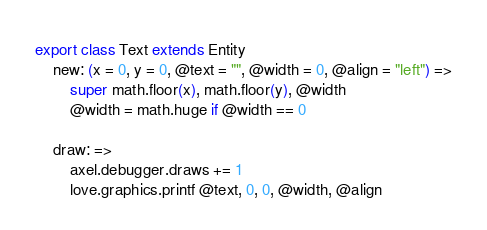<code> <loc_0><loc_0><loc_500><loc_500><_MoonScript_>export class Text extends Entity
	new: (x = 0, y = 0, @text = "", @width = 0, @align = "left") =>
		super math.floor(x), math.floor(y), @width
		@width = math.huge if @width == 0

	draw: =>
		axel.debugger.draws += 1
		love.graphics.printf @text, 0, 0, @width, @align</code> 